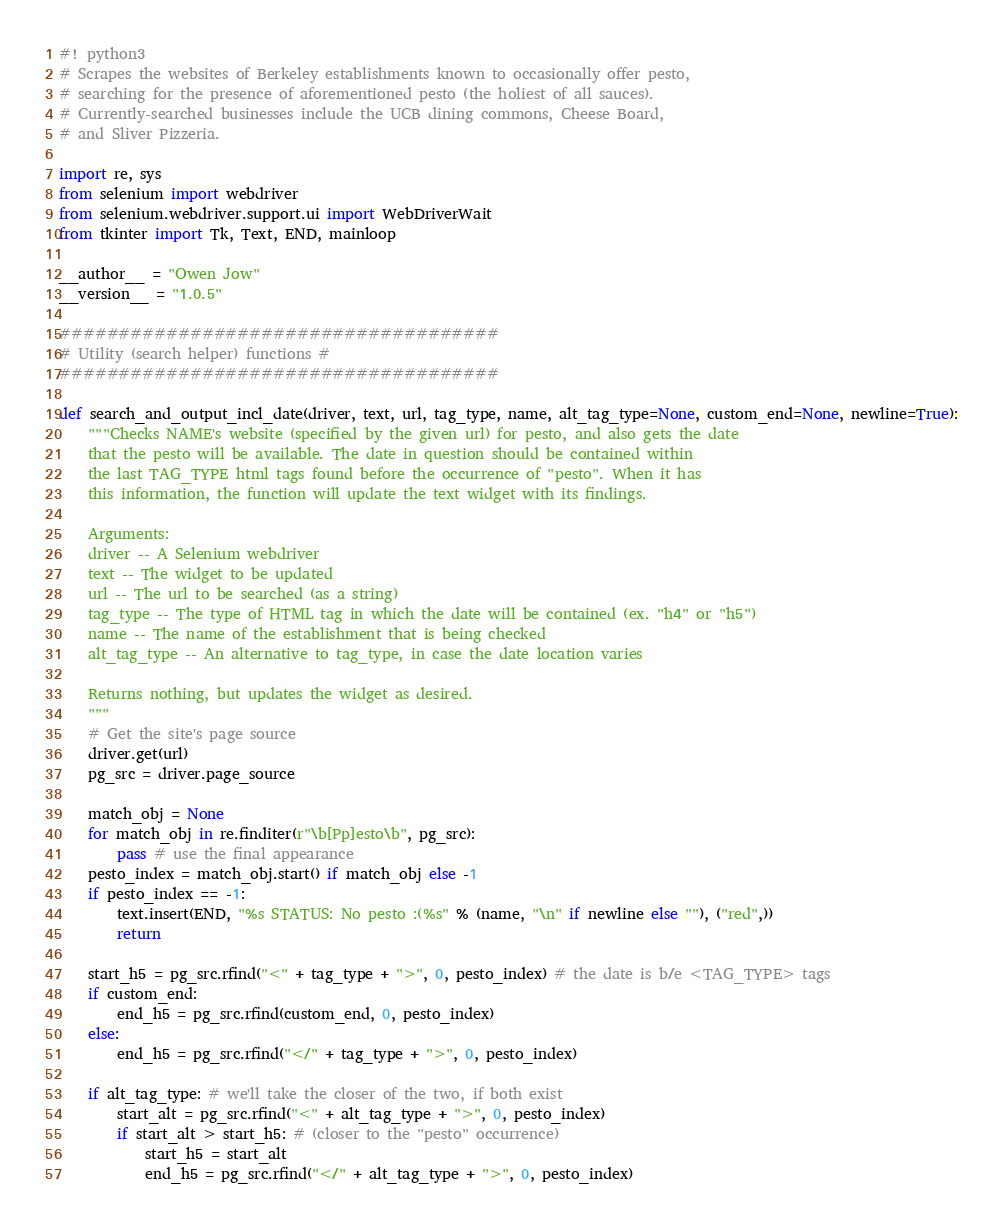<code> <loc_0><loc_0><loc_500><loc_500><_Python_>#! python3
# Scrapes the websites of Berkeley establishments known to occasionally offer pesto,
# searching for the presence of aforementioned pesto (the holiest of all sauces).
# Currently-searched businesses include the UCB dining commons, Cheese Board, 
# and Sliver Pizzeria.

import re, sys
from selenium import webdriver
from selenium.webdriver.support.ui import WebDriverWait
from tkinter import Tk, Text, END, mainloop

__author__ = "Owen Jow"
__version__ = "1.0.5"

#####################################
# Utility (search helper) functions # 
#####################################

def search_and_output_incl_date(driver, text, url, tag_type, name, alt_tag_type=None, custom_end=None, newline=True):
    """Checks NAME's website (specified by the given url) for pesto, and also gets the date
    that the pesto will be available. The date in question should be contained within 
    the last TAG_TYPE html tags found before the occurrence of "pesto". When it has 
    this information, the function will update the text widget with its findings.
    
    Arguments:
    driver -- A Selenium webdriver
    text -- The widget to be updated
    url -- The url to be searched (as a string)
    tag_type -- The type of HTML tag in which the date will be contained (ex. "h4" or "h5")
    name -- The name of the establishment that is being checked
    alt_tag_type -- An alternative to tag_type, in case the date location varies
    
    Returns nothing, but updates the widget as desired.
    """
    # Get the site's page source
    driver.get(url)
    pg_src = driver.page_source
    
    match_obj = None
    for match_obj in re.finditer(r"\b[Pp]esto\b", pg_src):
        pass # use the final appearance
    pesto_index = match_obj.start() if match_obj else -1
    if pesto_index == -1:
        text.insert(END, "%s STATUS: No pesto :(%s" % (name, "\n" if newline else ""), ("red",))
        return
    
    start_h5 = pg_src.rfind("<" + tag_type + ">", 0, pesto_index) # the date is b/e <TAG_TYPE> tags
    if custom_end:
        end_h5 = pg_src.rfind(custom_end, 0, pesto_index)
    else:
        end_h5 = pg_src.rfind("</" + tag_type + ">", 0, pesto_index)
    
    if alt_tag_type: # we'll take the closer of the two, if both exist
        start_alt = pg_src.rfind("<" + alt_tag_type + ">", 0, pesto_index)
        if start_alt > start_h5: # (closer to the "pesto" occurrence)
            start_h5 = start_alt
            end_h5 = pg_src.rfind("</" + alt_tag_type + ">", 0, pesto_index)
</code> 